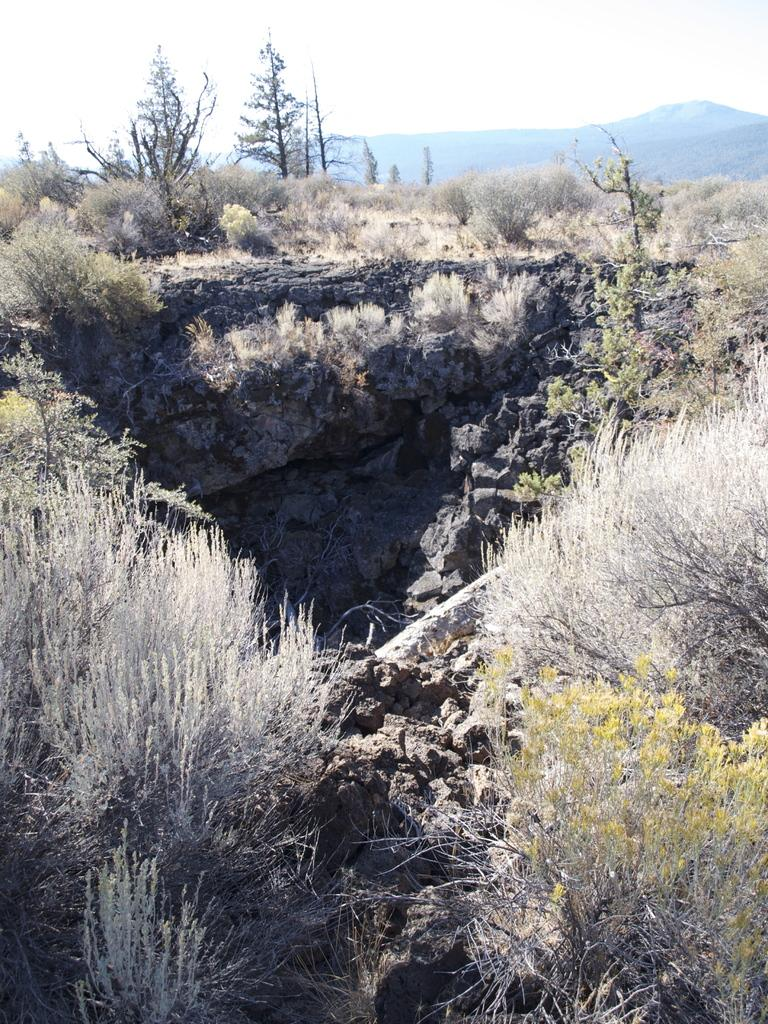What type of vegetation is present on the ground in the image? There are plants and trees on the ground in the image. What is located in the center of the image? There is a pit in the center of the image. What type of natural landform can be seen in the background of the image? There are mountains visible in the background of the image. What is visible at the top of the image? The sky is visible at the top of the image. How many babies are crawling on the ground in the image? There are no babies present in the image; it features plants, trees, a pit, mountains, and the sky. What type of net is used to catch the salt in the image? There is no net or salt present in the image. 